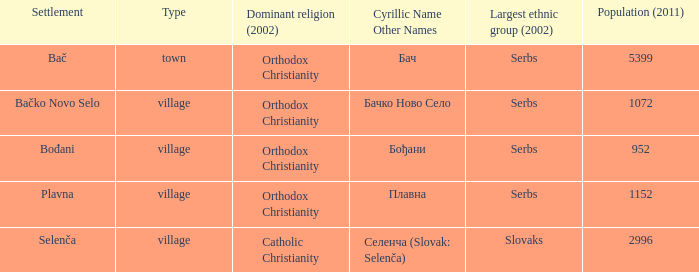What is the second way of writting плавна. Plavna. 